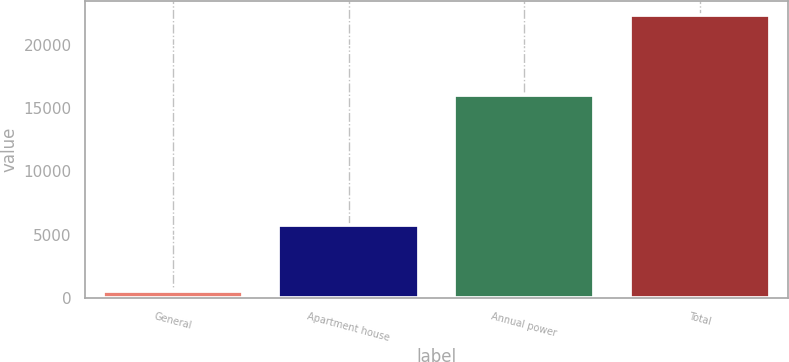Convert chart. <chart><loc_0><loc_0><loc_500><loc_500><bar_chart><fcel>General<fcel>Apartment house<fcel>Annual power<fcel>Total<nl><fcel>519<fcel>5779<fcel>16024<fcel>22322<nl></chart> 